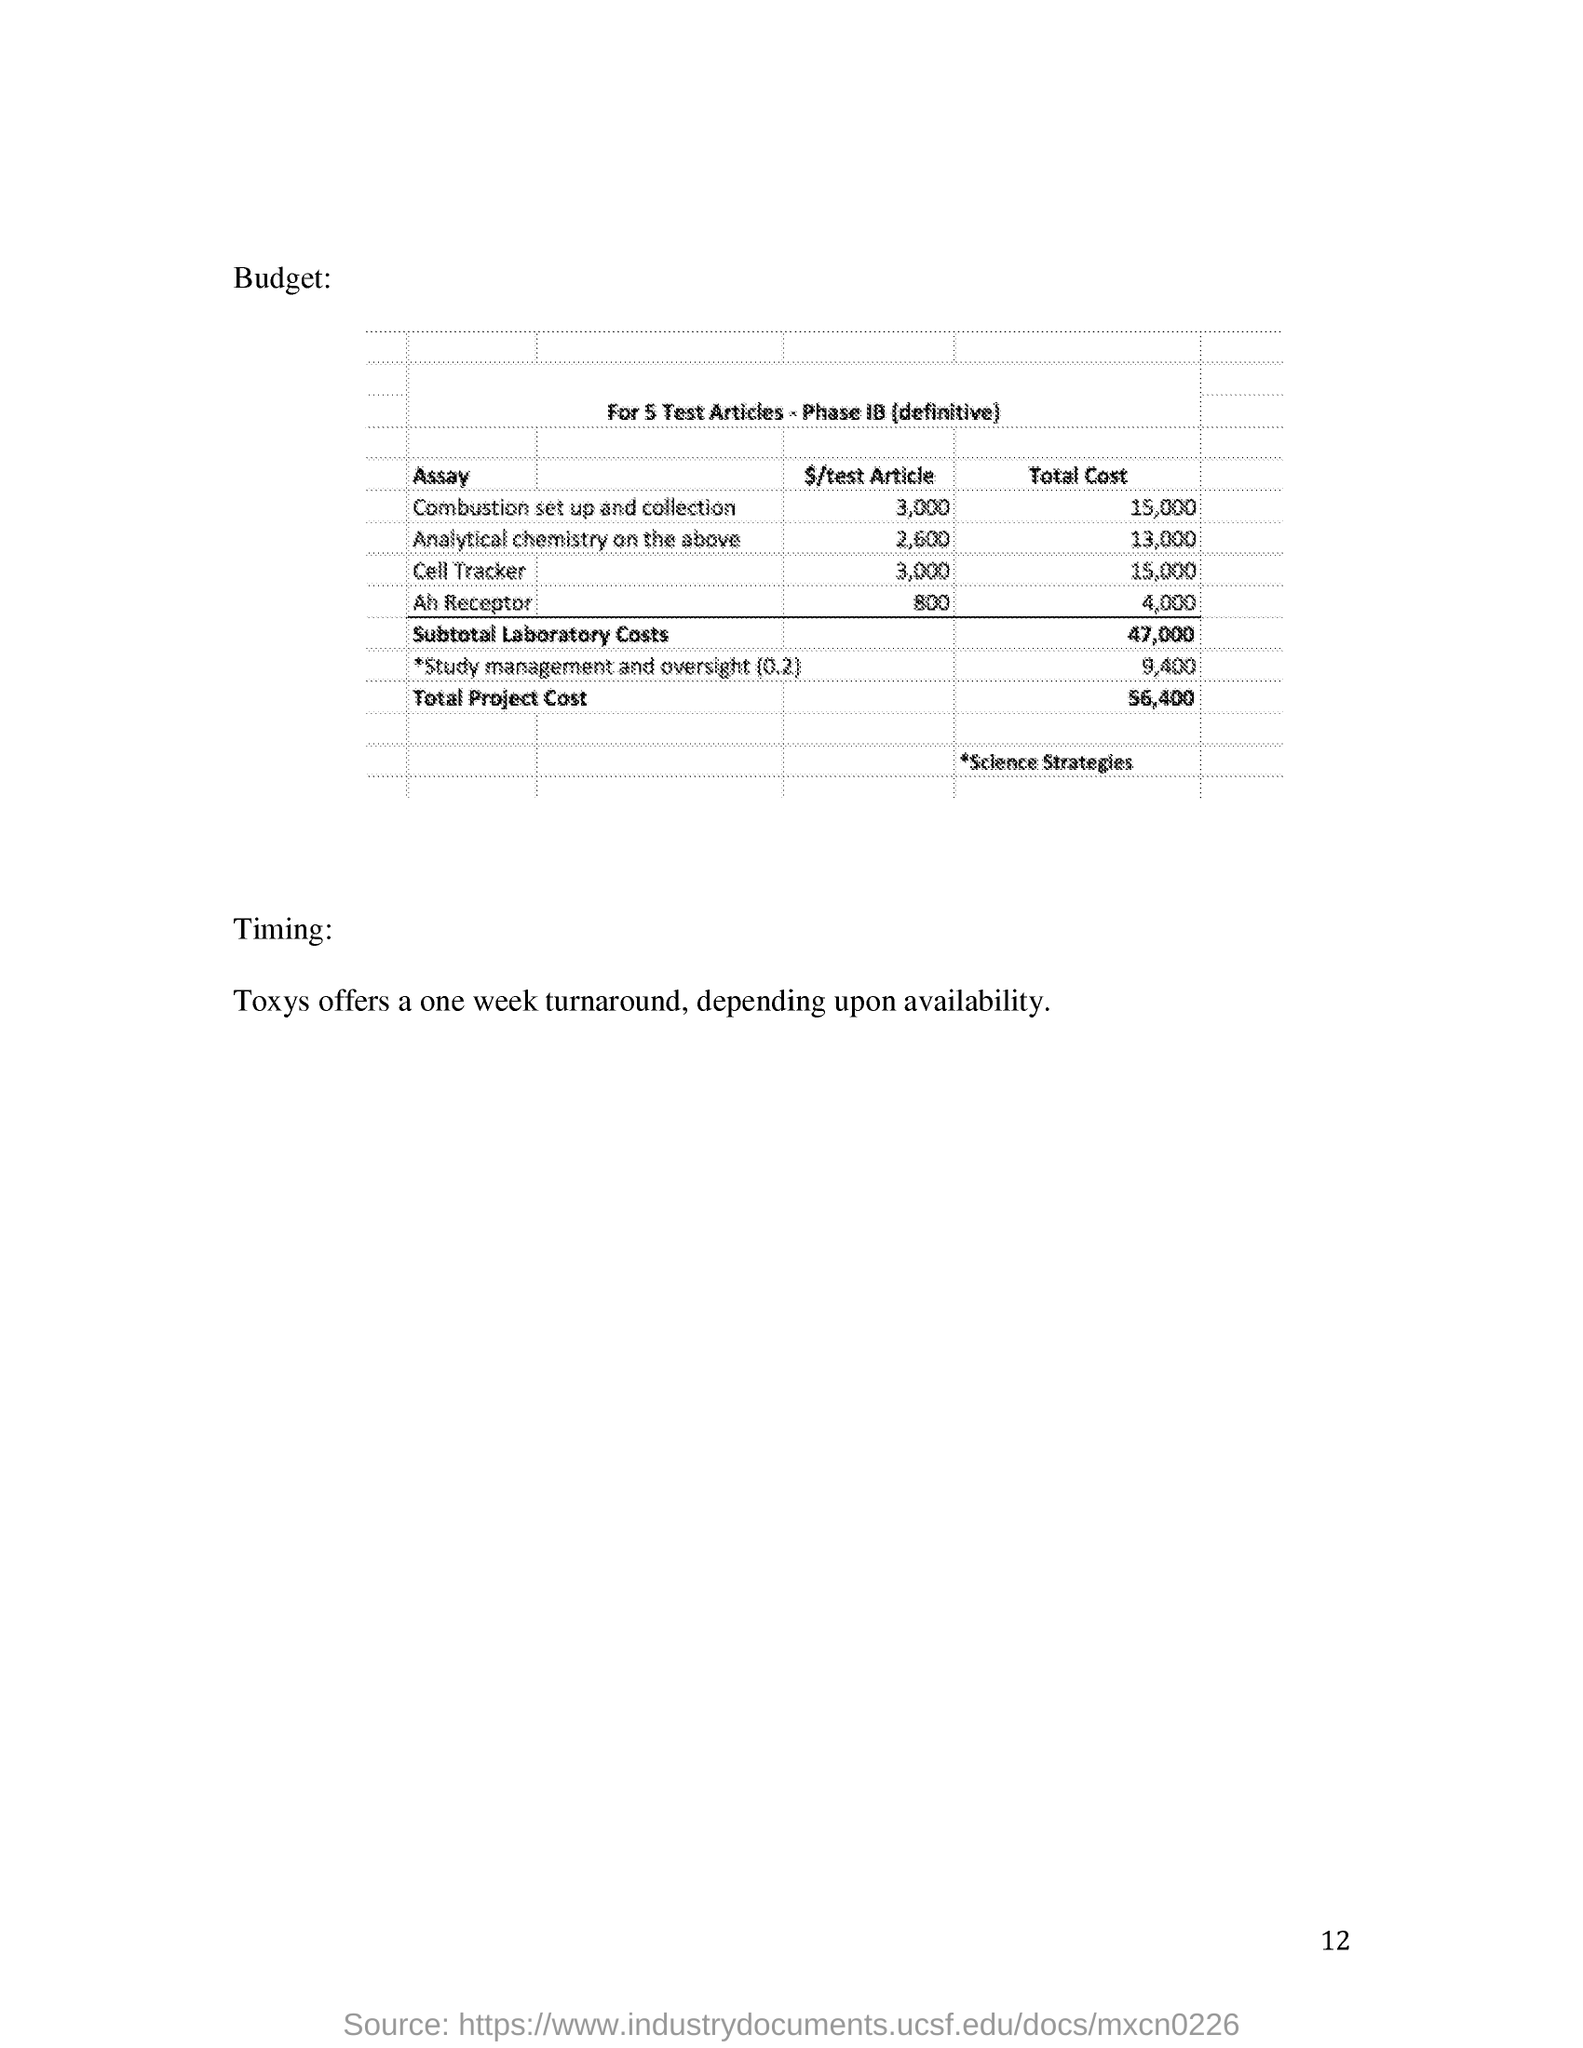Indicate a few pertinent items in this graphic. The heading of the budget table is 'For 5 Test Articles - Phase IB (definitive).'. The total project cost is estimated to be $56,400. Toxys offers a one-week turnaround time, subject to availability. 